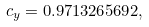Convert formula to latex. <formula><loc_0><loc_0><loc_500><loc_500>c _ { y } = 0 . 9 7 1 3 2 6 5 6 9 2 ,</formula> 